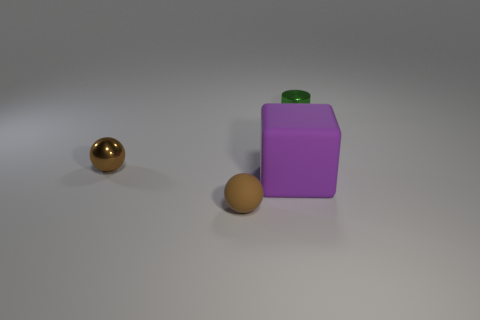What is the small thing that is behind the brown object that is behind the large cube made of?
Keep it short and to the point. Metal. What size is the brown matte ball to the right of the tiny brown ball that is behind the tiny thing that is in front of the tiny brown shiny thing?
Your answer should be compact. Small. What number of other tiny objects are made of the same material as the purple thing?
Provide a succinct answer. 1. There is a rubber thing that is right of the small brown thing that is in front of the large matte cube; what is its color?
Offer a terse response. Purple. How many objects are purple matte things or small things on the left side of the green cylinder?
Your response must be concise. 3. Is there a tiny shiny thing of the same color as the tiny rubber sphere?
Your answer should be very brief. Yes. What number of red things are either rubber things or tiny rubber things?
Your answer should be very brief. 0. How many other objects are there of the same size as the purple rubber cube?
Provide a short and direct response. 0. What number of tiny things are brown rubber spheres or green metal cylinders?
Your response must be concise. 2. Do the green thing and the ball in front of the big purple rubber block have the same size?
Give a very brief answer. Yes. 